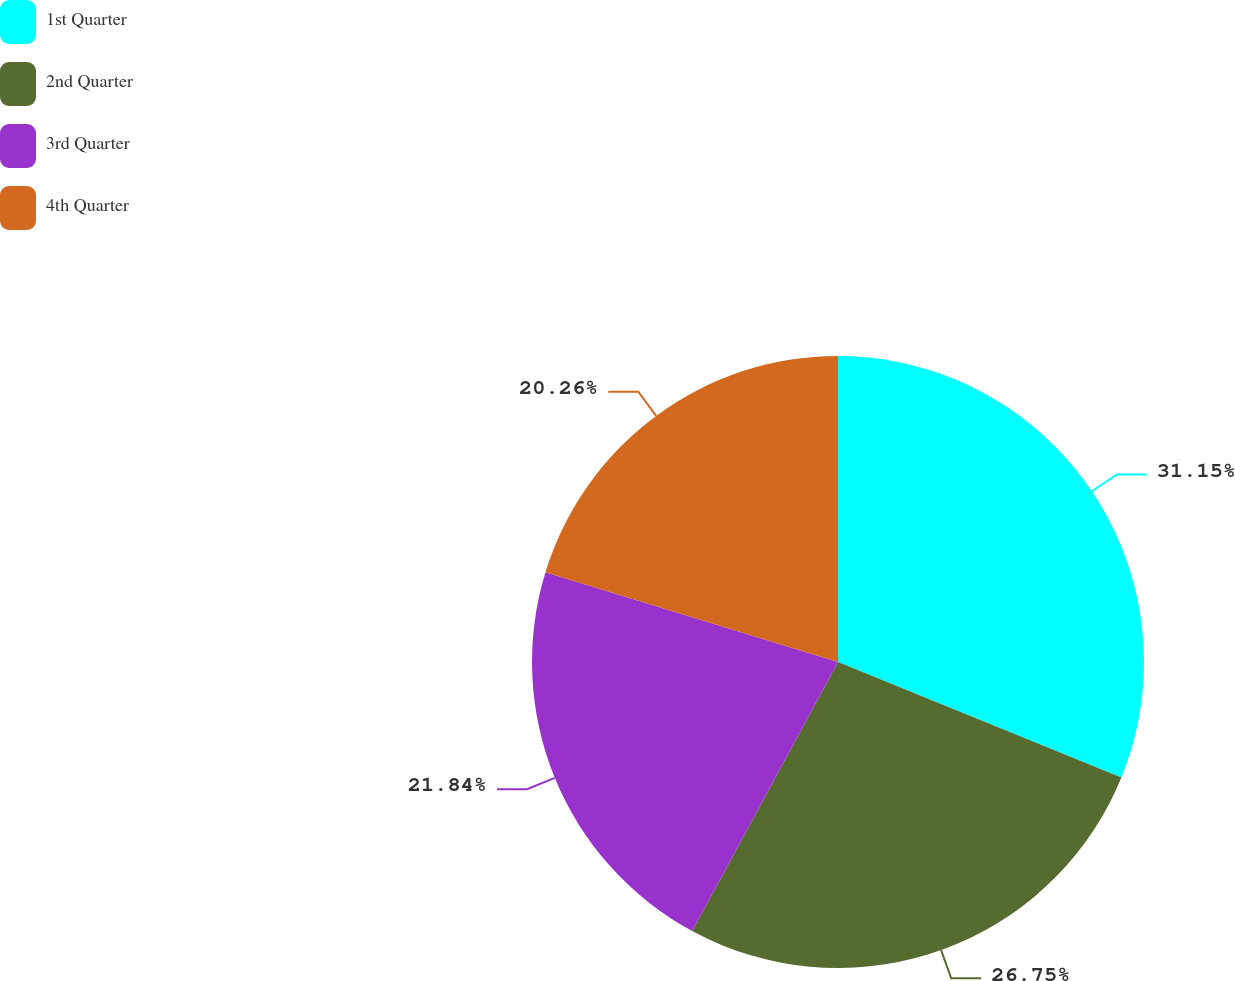Convert chart to OTSL. <chart><loc_0><loc_0><loc_500><loc_500><pie_chart><fcel>1st Quarter<fcel>2nd Quarter<fcel>3rd Quarter<fcel>4th Quarter<nl><fcel>31.16%<fcel>26.75%<fcel>21.84%<fcel>20.26%<nl></chart> 